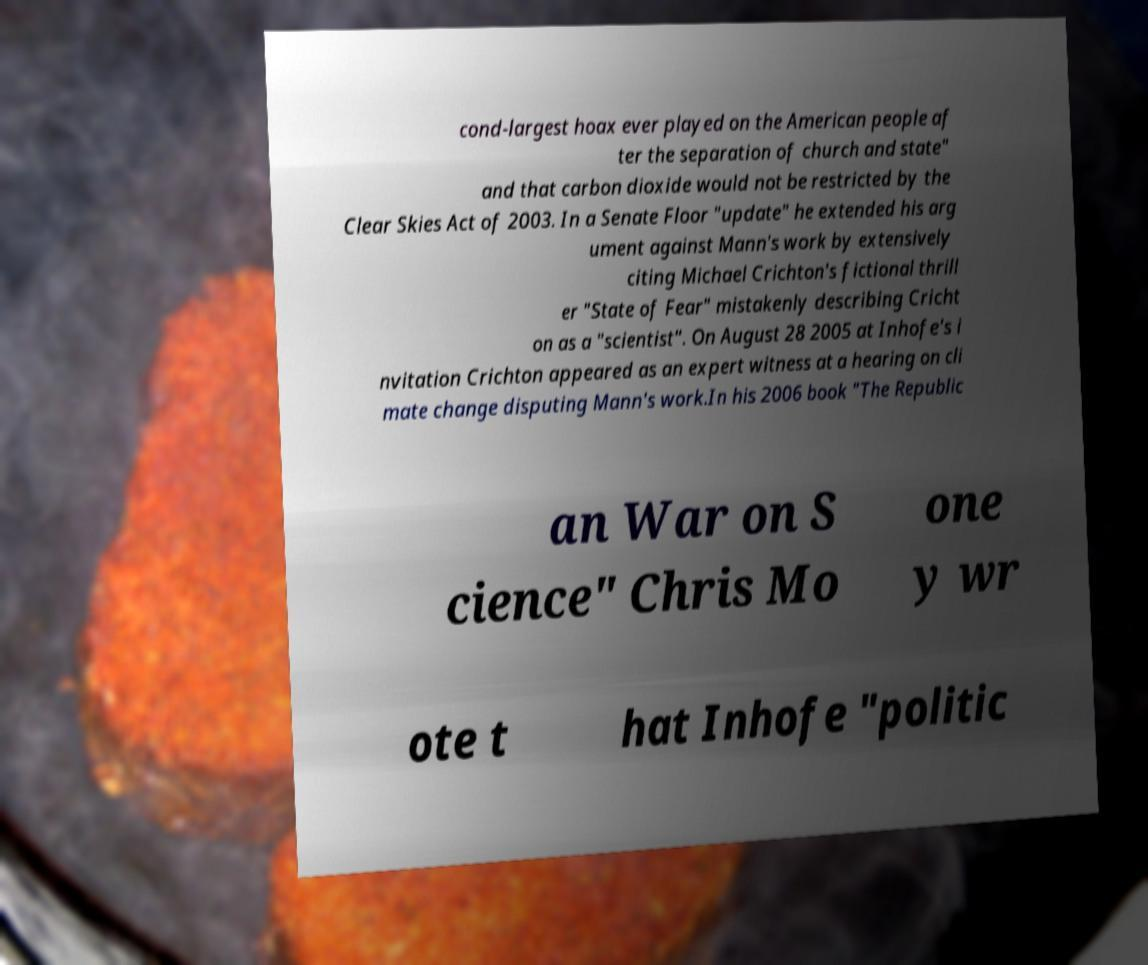Could you assist in decoding the text presented in this image and type it out clearly? cond-largest hoax ever played on the American people af ter the separation of church and state" and that carbon dioxide would not be restricted by the Clear Skies Act of 2003. In a Senate Floor "update" he extended his arg ument against Mann's work by extensively citing Michael Crichton's fictional thrill er "State of Fear" mistakenly describing Cricht on as a "scientist". On August 28 2005 at Inhofe's i nvitation Crichton appeared as an expert witness at a hearing on cli mate change disputing Mann's work.In his 2006 book "The Republic an War on S cience" Chris Mo one y wr ote t hat Inhofe "politic 